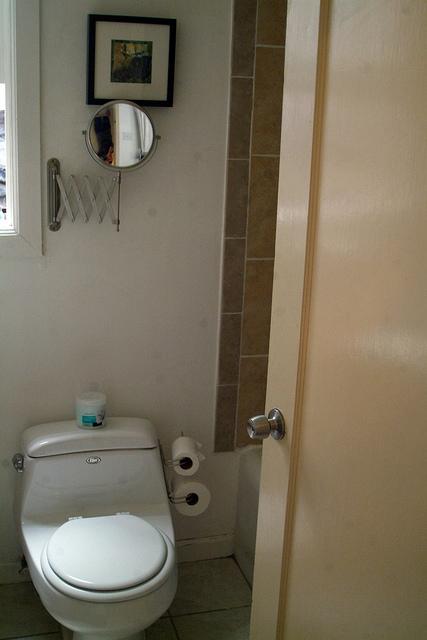What is the predominant color in this room?
Write a very short answer. White. Is this a public bathroom?
Quick response, please. No. How much toilet paper do you see is left?
Keep it brief. 2 rolls. How many rolls of toilet paper are there?
Concise answer only. 2. Where is the mirror?
Keep it brief. Above toilet. 